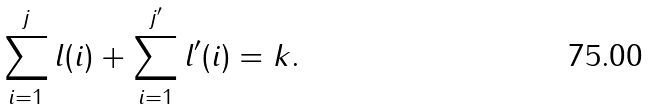<formula> <loc_0><loc_0><loc_500><loc_500>\sum _ { i = 1 } ^ { j } l ( i ) + \sum _ { i = 1 } ^ { j ^ { \prime } } l ^ { \prime } ( i ) = k .</formula> 